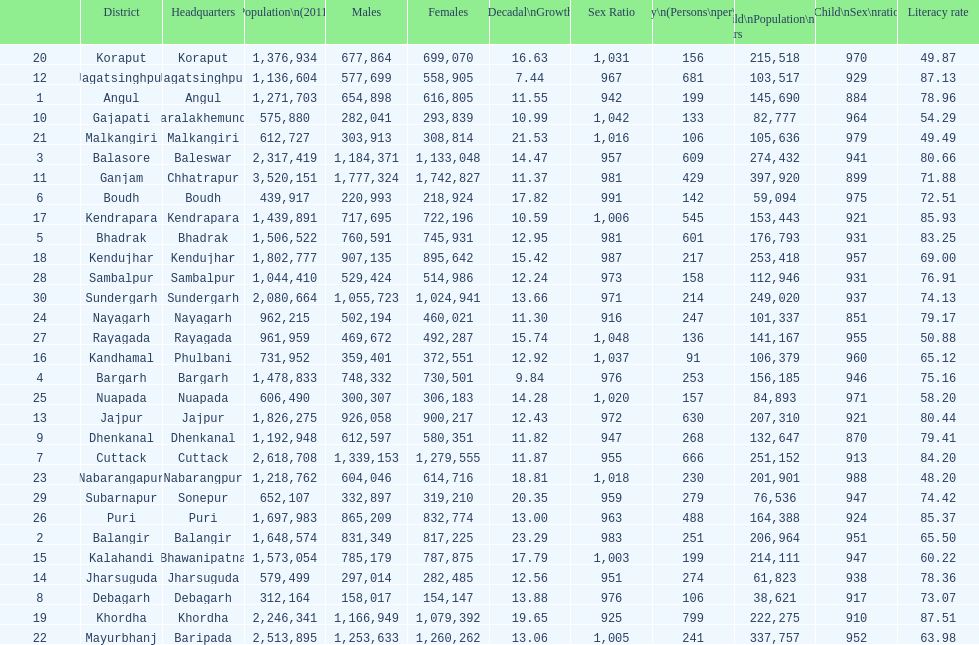Tell me a district that did not have a population over 600,000. Boudh. 